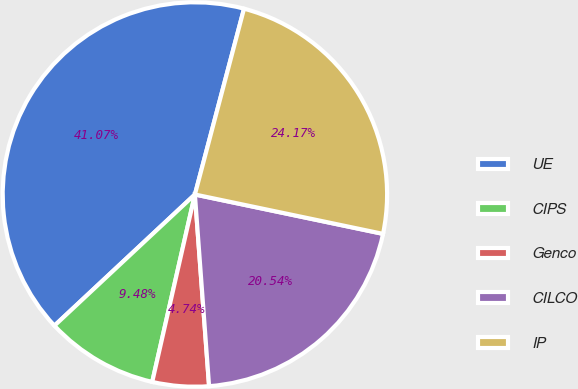<chart> <loc_0><loc_0><loc_500><loc_500><pie_chart><fcel>UE<fcel>CIPS<fcel>Genco<fcel>CILCO<fcel>IP<nl><fcel>41.07%<fcel>9.48%<fcel>4.74%<fcel>20.54%<fcel>24.17%<nl></chart> 